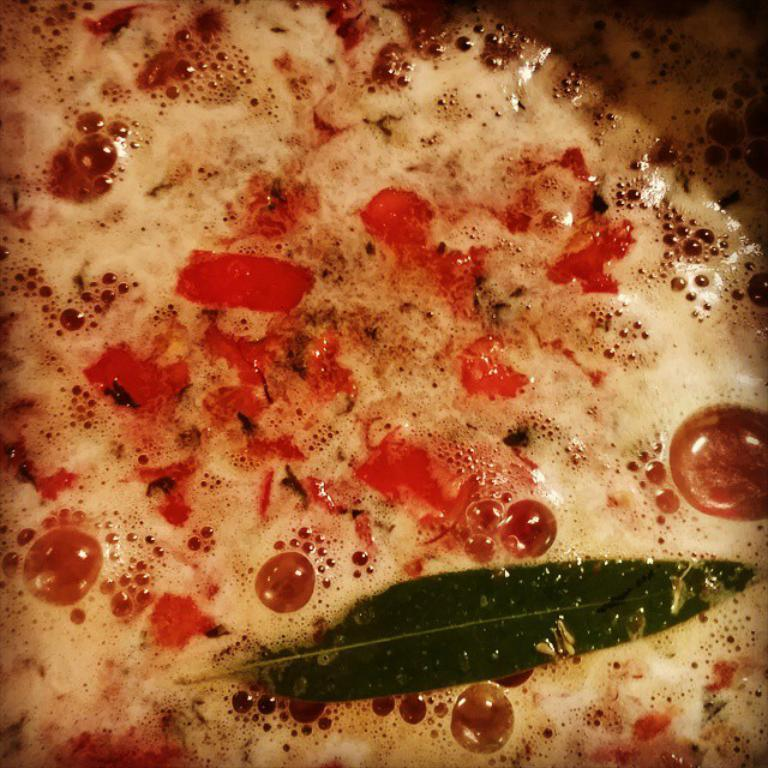What type of food item is present in the image? A: There is a food item in the image, but the specific type is not mentioned. Does the food item contain any liquid? Yes, the food item contains liquid. Are there any other items within the food item? Yes, there are other items in the food. Is there any vegetation visible on the food item? Yes, there is a leaf on the food item. Is there a volcano erupting in the background of the image? No, there is no volcano or any indication of heat or a farm present in the image. 